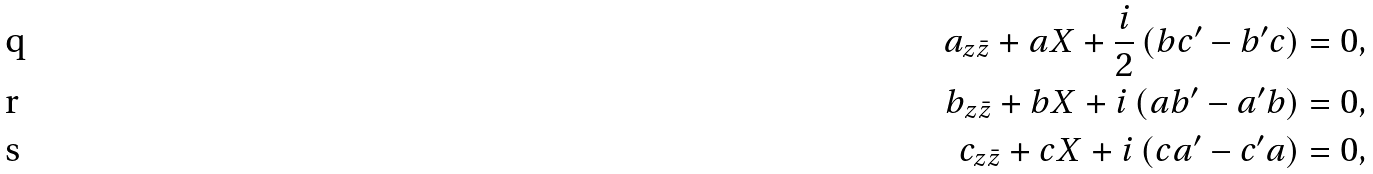<formula> <loc_0><loc_0><loc_500><loc_500>a _ { z \bar { z } } + a X + \frac { i } { 2 } \left ( b c ^ { \prime } - b ^ { \prime } c \right ) = 0 , \\ b _ { z \bar { z } } + b X + i \left ( a b ^ { \prime } - a ^ { \prime } b \right ) = 0 , \\ c _ { z \bar { z } } + c X + i \left ( c a ^ { \prime } - c ^ { \prime } a \right ) = 0 ,</formula> 